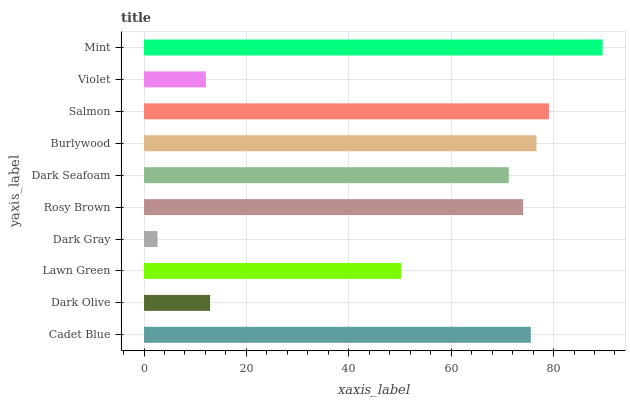Is Dark Gray the minimum?
Answer yes or no. Yes. Is Mint the maximum?
Answer yes or no. Yes. Is Dark Olive the minimum?
Answer yes or no. No. Is Dark Olive the maximum?
Answer yes or no. No. Is Cadet Blue greater than Dark Olive?
Answer yes or no. Yes. Is Dark Olive less than Cadet Blue?
Answer yes or no. Yes. Is Dark Olive greater than Cadet Blue?
Answer yes or no. No. Is Cadet Blue less than Dark Olive?
Answer yes or no. No. Is Rosy Brown the high median?
Answer yes or no. Yes. Is Dark Seafoam the low median?
Answer yes or no. Yes. Is Mint the high median?
Answer yes or no. No. Is Burlywood the low median?
Answer yes or no. No. 